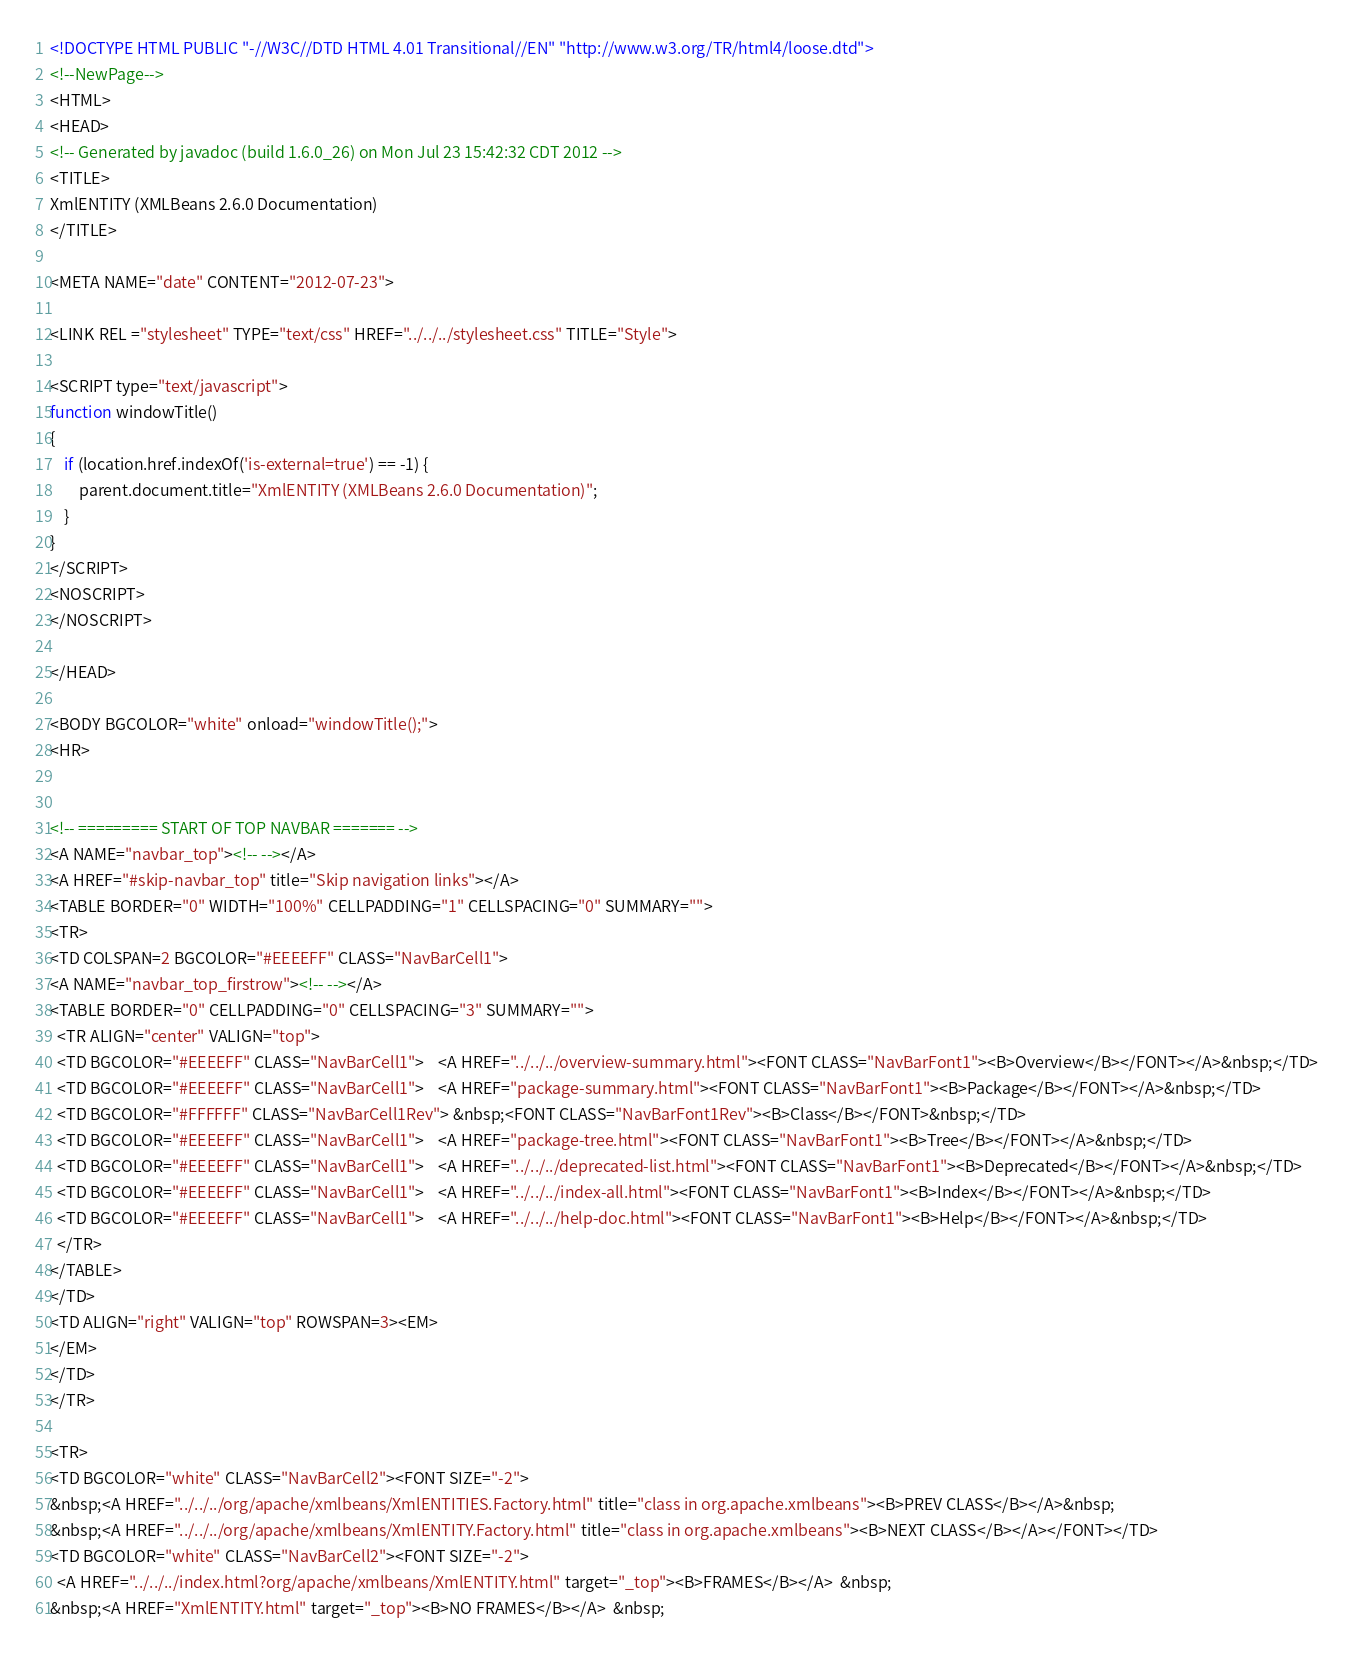<code> <loc_0><loc_0><loc_500><loc_500><_HTML_><!DOCTYPE HTML PUBLIC "-//W3C//DTD HTML 4.01 Transitional//EN" "http://www.w3.org/TR/html4/loose.dtd">
<!--NewPage-->
<HTML>
<HEAD>
<!-- Generated by javadoc (build 1.6.0_26) on Mon Jul 23 15:42:32 CDT 2012 -->
<TITLE>
XmlENTITY (XMLBeans 2.6.0 Documentation)
</TITLE>

<META NAME="date" CONTENT="2012-07-23">

<LINK REL ="stylesheet" TYPE="text/css" HREF="../../../stylesheet.css" TITLE="Style">

<SCRIPT type="text/javascript">
function windowTitle()
{
    if (location.href.indexOf('is-external=true') == -1) {
        parent.document.title="XmlENTITY (XMLBeans 2.6.0 Documentation)";
    }
}
</SCRIPT>
<NOSCRIPT>
</NOSCRIPT>

</HEAD>

<BODY BGCOLOR="white" onload="windowTitle();">
<HR>


<!-- ========= START OF TOP NAVBAR ======= -->
<A NAME="navbar_top"><!-- --></A>
<A HREF="#skip-navbar_top" title="Skip navigation links"></A>
<TABLE BORDER="0" WIDTH="100%" CELLPADDING="1" CELLSPACING="0" SUMMARY="">
<TR>
<TD COLSPAN=2 BGCOLOR="#EEEEFF" CLASS="NavBarCell1">
<A NAME="navbar_top_firstrow"><!-- --></A>
<TABLE BORDER="0" CELLPADDING="0" CELLSPACING="3" SUMMARY="">
  <TR ALIGN="center" VALIGN="top">
  <TD BGCOLOR="#EEEEFF" CLASS="NavBarCell1">    <A HREF="../../../overview-summary.html"><FONT CLASS="NavBarFont1"><B>Overview</B></FONT></A>&nbsp;</TD>
  <TD BGCOLOR="#EEEEFF" CLASS="NavBarCell1">    <A HREF="package-summary.html"><FONT CLASS="NavBarFont1"><B>Package</B></FONT></A>&nbsp;</TD>
  <TD BGCOLOR="#FFFFFF" CLASS="NavBarCell1Rev"> &nbsp;<FONT CLASS="NavBarFont1Rev"><B>Class</B></FONT>&nbsp;</TD>
  <TD BGCOLOR="#EEEEFF" CLASS="NavBarCell1">    <A HREF="package-tree.html"><FONT CLASS="NavBarFont1"><B>Tree</B></FONT></A>&nbsp;</TD>
  <TD BGCOLOR="#EEEEFF" CLASS="NavBarCell1">    <A HREF="../../../deprecated-list.html"><FONT CLASS="NavBarFont1"><B>Deprecated</B></FONT></A>&nbsp;</TD>
  <TD BGCOLOR="#EEEEFF" CLASS="NavBarCell1">    <A HREF="../../../index-all.html"><FONT CLASS="NavBarFont1"><B>Index</B></FONT></A>&nbsp;</TD>
  <TD BGCOLOR="#EEEEFF" CLASS="NavBarCell1">    <A HREF="../../../help-doc.html"><FONT CLASS="NavBarFont1"><B>Help</B></FONT></A>&nbsp;</TD>
  </TR>
</TABLE>
</TD>
<TD ALIGN="right" VALIGN="top" ROWSPAN=3><EM>
</EM>
</TD>
</TR>

<TR>
<TD BGCOLOR="white" CLASS="NavBarCell2"><FONT SIZE="-2">
&nbsp;<A HREF="../../../org/apache/xmlbeans/XmlENTITIES.Factory.html" title="class in org.apache.xmlbeans"><B>PREV CLASS</B></A>&nbsp;
&nbsp;<A HREF="../../../org/apache/xmlbeans/XmlENTITY.Factory.html" title="class in org.apache.xmlbeans"><B>NEXT CLASS</B></A></FONT></TD>
<TD BGCOLOR="white" CLASS="NavBarCell2"><FONT SIZE="-2">
  <A HREF="../../../index.html?org/apache/xmlbeans/XmlENTITY.html" target="_top"><B>FRAMES</B></A>  &nbsp;
&nbsp;<A HREF="XmlENTITY.html" target="_top"><B>NO FRAMES</B></A>  &nbsp;</code> 